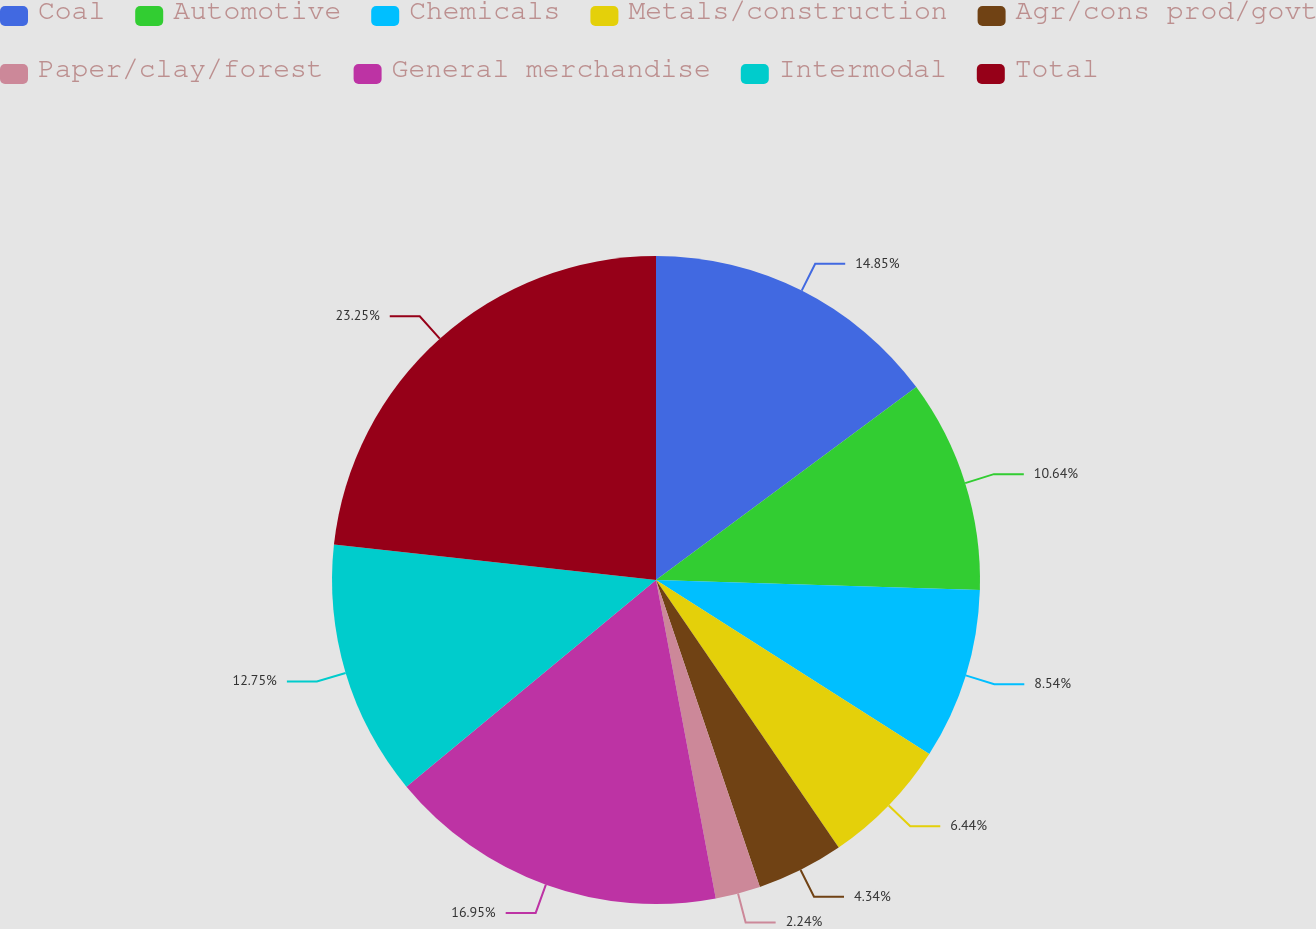Convert chart. <chart><loc_0><loc_0><loc_500><loc_500><pie_chart><fcel>Coal<fcel>Automotive<fcel>Chemicals<fcel>Metals/construction<fcel>Agr/cons prod/govt<fcel>Paper/clay/forest<fcel>General merchandise<fcel>Intermodal<fcel>Total<nl><fcel>14.85%<fcel>10.64%<fcel>8.54%<fcel>6.44%<fcel>4.34%<fcel>2.24%<fcel>16.95%<fcel>12.75%<fcel>23.26%<nl></chart> 